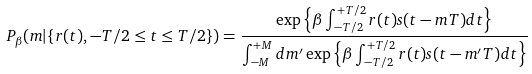<formula> <loc_0><loc_0><loc_500><loc_500>P _ { \beta } ( m | \{ r ( t ) , - T / 2 \leq t \leq T / 2 \} ) = \frac { \exp \left \{ \beta \int _ { - T / 2 } ^ { + T / 2 } r ( t ) s ( t - m T ) d t \right \} } { \int _ { - M } ^ { + M } d m ^ { \prime } \exp \left \{ \beta \int _ { - T / 2 } ^ { + T / 2 } r ( t ) s ( t - m ^ { \prime } T ) d t \right \} }</formula> 